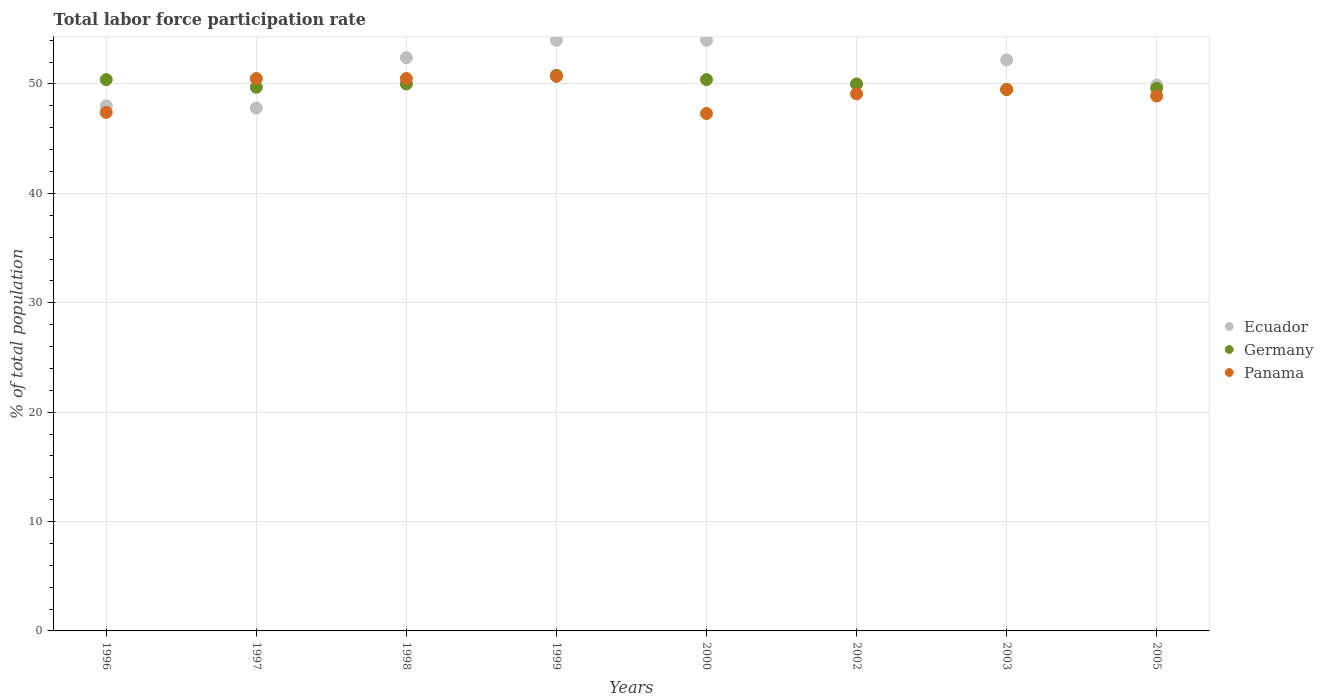Is the number of dotlines equal to the number of legend labels?
Keep it short and to the point. Yes. What is the total labor force participation rate in Germany in 1997?
Your answer should be compact. 49.7. Across all years, what is the maximum total labor force participation rate in Ecuador?
Provide a short and direct response. 54. Across all years, what is the minimum total labor force participation rate in Ecuador?
Provide a succinct answer. 47.8. In which year was the total labor force participation rate in Germany minimum?
Give a very brief answer. 2003. What is the total total labor force participation rate in Panama in the graph?
Provide a succinct answer. 393.9. What is the difference between the total labor force participation rate in Germany in 1997 and that in 2000?
Provide a short and direct response. -0.7. What is the difference between the total labor force participation rate in Ecuador in 2002 and the total labor force participation rate in Panama in 1997?
Provide a short and direct response. -0.5. What is the average total labor force participation rate in Germany per year?
Provide a succinct answer. 50.05. In the year 1997, what is the difference between the total labor force participation rate in Ecuador and total labor force participation rate in Panama?
Make the answer very short. -2.7. What is the ratio of the total labor force participation rate in Panama in 1997 to that in 2000?
Keep it short and to the point. 1.07. What is the difference between the highest and the second highest total labor force participation rate in Panama?
Provide a succinct answer. 0.2. What is the difference between the highest and the lowest total labor force participation rate in Ecuador?
Keep it short and to the point. 6.2. In how many years, is the total labor force participation rate in Germany greater than the average total labor force participation rate in Germany taken over all years?
Your response must be concise. 3. Is it the case that in every year, the sum of the total labor force participation rate in Ecuador and total labor force participation rate in Germany  is greater than the total labor force participation rate in Panama?
Offer a very short reply. Yes. Is the total labor force participation rate in Panama strictly greater than the total labor force participation rate in Ecuador over the years?
Provide a short and direct response. No. Is the total labor force participation rate in Germany strictly less than the total labor force participation rate in Ecuador over the years?
Make the answer very short. No. What is the difference between two consecutive major ticks on the Y-axis?
Your response must be concise. 10. How many legend labels are there?
Give a very brief answer. 3. What is the title of the graph?
Make the answer very short. Total labor force participation rate. What is the label or title of the Y-axis?
Your answer should be very brief. % of total population. What is the % of total population of Ecuador in 1996?
Make the answer very short. 48. What is the % of total population in Germany in 1996?
Make the answer very short. 50.4. What is the % of total population of Panama in 1996?
Give a very brief answer. 47.4. What is the % of total population in Ecuador in 1997?
Ensure brevity in your answer.  47.8. What is the % of total population in Germany in 1997?
Provide a succinct answer. 49.7. What is the % of total population of Panama in 1997?
Make the answer very short. 50.5. What is the % of total population of Ecuador in 1998?
Your answer should be compact. 52.4. What is the % of total population of Germany in 1998?
Offer a very short reply. 50. What is the % of total population in Panama in 1998?
Give a very brief answer. 50.5. What is the % of total population of Ecuador in 1999?
Your answer should be very brief. 54. What is the % of total population in Germany in 1999?
Offer a terse response. 50.8. What is the % of total population of Panama in 1999?
Your answer should be compact. 50.7. What is the % of total population in Germany in 2000?
Your response must be concise. 50.4. What is the % of total population of Panama in 2000?
Provide a short and direct response. 47.3. What is the % of total population of Ecuador in 2002?
Provide a succinct answer. 50. What is the % of total population in Germany in 2002?
Your answer should be very brief. 50. What is the % of total population in Panama in 2002?
Provide a succinct answer. 49.1. What is the % of total population of Ecuador in 2003?
Give a very brief answer. 52.2. What is the % of total population in Germany in 2003?
Provide a short and direct response. 49.5. What is the % of total population of Panama in 2003?
Your answer should be compact. 49.5. What is the % of total population of Ecuador in 2005?
Provide a succinct answer. 49.9. What is the % of total population of Germany in 2005?
Your answer should be very brief. 49.6. What is the % of total population of Panama in 2005?
Keep it short and to the point. 48.9. Across all years, what is the maximum % of total population of Germany?
Keep it short and to the point. 50.8. Across all years, what is the maximum % of total population in Panama?
Offer a very short reply. 50.7. Across all years, what is the minimum % of total population of Ecuador?
Provide a succinct answer. 47.8. Across all years, what is the minimum % of total population in Germany?
Offer a very short reply. 49.5. Across all years, what is the minimum % of total population in Panama?
Give a very brief answer. 47.3. What is the total % of total population of Ecuador in the graph?
Offer a terse response. 408.3. What is the total % of total population of Germany in the graph?
Give a very brief answer. 400.4. What is the total % of total population in Panama in the graph?
Provide a succinct answer. 393.9. What is the difference between the % of total population of Ecuador in 1996 and that in 1997?
Provide a succinct answer. 0.2. What is the difference between the % of total population of Panama in 1996 and that in 1997?
Ensure brevity in your answer.  -3.1. What is the difference between the % of total population in Panama in 1996 and that in 1998?
Your answer should be very brief. -3.1. What is the difference between the % of total population of Ecuador in 1996 and that in 1999?
Your answer should be very brief. -6. What is the difference between the % of total population of Germany in 1996 and that in 1999?
Offer a very short reply. -0.4. What is the difference between the % of total population of Germany in 1996 and that in 2000?
Ensure brevity in your answer.  0. What is the difference between the % of total population in Panama in 1996 and that in 2000?
Your answer should be very brief. 0.1. What is the difference between the % of total population of Germany in 1996 and that in 2002?
Provide a short and direct response. 0.4. What is the difference between the % of total population of Panama in 1996 and that in 2002?
Give a very brief answer. -1.7. What is the difference between the % of total population of Germany in 1996 and that in 2003?
Provide a short and direct response. 0.9. What is the difference between the % of total population in Germany in 1996 and that in 2005?
Make the answer very short. 0.8. What is the difference between the % of total population in Ecuador in 1997 and that in 1998?
Your answer should be very brief. -4.6. What is the difference between the % of total population of Germany in 1997 and that in 1998?
Keep it short and to the point. -0.3. What is the difference between the % of total population in Panama in 1997 and that in 1998?
Ensure brevity in your answer.  0. What is the difference between the % of total population of Panama in 1997 and that in 1999?
Provide a succinct answer. -0.2. What is the difference between the % of total population of Ecuador in 1997 and that in 2000?
Provide a succinct answer. -6.2. What is the difference between the % of total population in Panama in 1997 and that in 2000?
Offer a terse response. 3.2. What is the difference between the % of total population in Ecuador in 1997 and that in 2003?
Your response must be concise. -4.4. What is the difference between the % of total population in Panama in 1997 and that in 2003?
Provide a succinct answer. 1. What is the difference between the % of total population in Ecuador in 1997 and that in 2005?
Offer a very short reply. -2.1. What is the difference between the % of total population in Germany in 1997 and that in 2005?
Provide a succinct answer. 0.1. What is the difference between the % of total population of Panama in 1997 and that in 2005?
Provide a short and direct response. 1.6. What is the difference between the % of total population of Ecuador in 1998 and that in 1999?
Your answer should be very brief. -1.6. What is the difference between the % of total population in Ecuador in 1998 and that in 2000?
Your answer should be very brief. -1.6. What is the difference between the % of total population of Germany in 1998 and that in 2000?
Your answer should be compact. -0.4. What is the difference between the % of total population of Ecuador in 1998 and that in 2002?
Offer a terse response. 2.4. What is the difference between the % of total population of Ecuador in 1998 and that in 2003?
Make the answer very short. 0.2. What is the difference between the % of total population of Germany in 1998 and that in 2003?
Provide a short and direct response. 0.5. What is the difference between the % of total population in Panama in 1998 and that in 2003?
Offer a terse response. 1. What is the difference between the % of total population of Panama in 1998 and that in 2005?
Your answer should be very brief. 1.6. What is the difference between the % of total population of Ecuador in 1999 and that in 2002?
Keep it short and to the point. 4. What is the difference between the % of total population of Germany in 1999 and that in 2002?
Offer a terse response. 0.8. What is the difference between the % of total population in Panama in 1999 and that in 2002?
Offer a terse response. 1.6. What is the difference between the % of total population of Ecuador in 1999 and that in 2003?
Your answer should be very brief. 1.8. What is the difference between the % of total population in Germany in 1999 and that in 2003?
Offer a terse response. 1.3. What is the difference between the % of total population of Ecuador in 1999 and that in 2005?
Provide a short and direct response. 4.1. What is the difference between the % of total population in Germany in 1999 and that in 2005?
Provide a short and direct response. 1.2. What is the difference between the % of total population in Panama in 1999 and that in 2005?
Keep it short and to the point. 1.8. What is the difference between the % of total population in Germany in 2000 and that in 2002?
Make the answer very short. 0.4. What is the difference between the % of total population in Panama in 2000 and that in 2002?
Make the answer very short. -1.8. What is the difference between the % of total population in Ecuador in 2000 and that in 2003?
Offer a very short reply. 1.8. What is the difference between the % of total population in Panama in 2000 and that in 2003?
Provide a short and direct response. -2.2. What is the difference between the % of total population in Panama in 2000 and that in 2005?
Ensure brevity in your answer.  -1.6. What is the difference between the % of total population of Germany in 2002 and that in 2003?
Offer a terse response. 0.5. What is the difference between the % of total population of Germany in 2002 and that in 2005?
Your response must be concise. 0.4. What is the difference between the % of total population in Panama in 2002 and that in 2005?
Offer a very short reply. 0.2. What is the difference between the % of total population of Panama in 2003 and that in 2005?
Your response must be concise. 0.6. What is the difference between the % of total population in Germany in 1996 and the % of total population in Panama in 1997?
Ensure brevity in your answer.  -0.1. What is the difference between the % of total population in Germany in 1996 and the % of total population in Panama in 1998?
Keep it short and to the point. -0.1. What is the difference between the % of total population in Ecuador in 1996 and the % of total population in Germany in 1999?
Ensure brevity in your answer.  -2.8. What is the difference between the % of total population in Ecuador in 1996 and the % of total population in Panama in 1999?
Provide a succinct answer. -2.7. What is the difference between the % of total population in Germany in 1996 and the % of total population in Panama in 1999?
Provide a succinct answer. -0.3. What is the difference between the % of total population of Germany in 1996 and the % of total population of Panama in 2000?
Keep it short and to the point. 3.1. What is the difference between the % of total population in Ecuador in 1996 and the % of total population in Germany in 2002?
Your answer should be compact. -2. What is the difference between the % of total population of Germany in 1996 and the % of total population of Panama in 2002?
Keep it short and to the point. 1.3. What is the difference between the % of total population in Ecuador in 1996 and the % of total population in Germany in 2003?
Make the answer very short. -1.5. What is the difference between the % of total population of Ecuador in 1996 and the % of total population of Germany in 2005?
Provide a succinct answer. -1.6. What is the difference between the % of total population in Ecuador in 1996 and the % of total population in Panama in 2005?
Keep it short and to the point. -0.9. What is the difference between the % of total population in Ecuador in 1997 and the % of total population in Panama in 1998?
Your answer should be very brief. -2.7. What is the difference between the % of total population of Germany in 1997 and the % of total population of Panama in 1998?
Your answer should be very brief. -0.8. What is the difference between the % of total population in Ecuador in 1997 and the % of total population in Germany in 1999?
Offer a terse response. -3. What is the difference between the % of total population of Germany in 1997 and the % of total population of Panama in 1999?
Your answer should be very brief. -1. What is the difference between the % of total population of Ecuador in 1997 and the % of total population of Germany in 2000?
Offer a terse response. -2.6. What is the difference between the % of total population of Ecuador in 1997 and the % of total population of Panama in 2000?
Offer a terse response. 0.5. What is the difference between the % of total population of Germany in 1997 and the % of total population of Panama in 2000?
Your answer should be very brief. 2.4. What is the difference between the % of total population of Ecuador in 1997 and the % of total population of Germany in 2002?
Ensure brevity in your answer.  -2.2. What is the difference between the % of total population in Ecuador in 1997 and the % of total population in Panama in 2002?
Ensure brevity in your answer.  -1.3. What is the difference between the % of total population of Germany in 1997 and the % of total population of Panama in 2002?
Keep it short and to the point. 0.6. What is the difference between the % of total population in Ecuador in 1997 and the % of total population in Germany in 2003?
Keep it short and to the point. -1.7. What is the difference between the % of total population of Germany in 1997 and the % of total population of Panama in 2003?
Ensure brevity in your answer.  0.2. What is the difference between the % of total population in Ecuador in 1997 and the % of total population in Panama in 2005?
Give a very brief answer. -1.1. What is the difference between the % of total population in Germany in 1997 and the % of total population in Panama in 2005?
Make the answer very short. 0.8. What is the difference between the % of total population in Ecuador in 1998 and the % of total population in Germany in 1999?
Offer a very short reply. 1.6. What is the difference between the % of total population of Ecuador in 1998 and the % of total population of Germany in 2000?
Offer a terse response. 2. What is the difference between the % of total population of Germany in 1998 and the % of total population of Panama in 2000?
Your answer should be compact. 2.7. What is the difference between the % of total population of Ecuador in 1998 and the % of total population of Panama in 2002?
Offer a terse response. 3.3. What is the difference between the % of total population of Germany in 1998 and the % of total population of Panama in 2002?
Provide a succinct answer. 0.9. What is the difference between the % of total population of Ecuador in 1998 and the % of total population of Germany in 2003?
Offer a very short reply. 2.9. What is the difference between the % of total population of Ecuador in 1998 and the % of total population of Panama in 2003?
Your answer should be very brief. 2.9. What is the difference between the % of total population of Germany in 1998 and the % of total population of Panama in 2003?
Give a very brief answer. 0.5. What is the difference between the % of total population of Ecuador in 1998 and the % of total population of Panama in 2005?
Your answer should be very brief. 3.5. What is the difference between the % of total population in Ecuador in 1999 and the % of total population in Germany in 2000?
Give a very brief answer. 3.6. What is the difference between the % of total population of Germany in 1999 and the % of total population of Panama in 2000?
Give a very brief answer. 3.5. What is the difference between the % of total population of Ecuador in 1999 and the % of total population of Panama in 2002?
Provide a succinct answer. 4.9. What is the difference between the % of total population of Germany in 1999 and the % of total population of Panama in 2002?
Give a very brief answer. 1.7. What is the difference between the % of total population in Ecuador in 1999 and the % of total population in Germany in 2003?
Your answer should be very brief. 4.5. What is the difference between the % of total population of Ecuador in 1999 and the % of total population of Panama in 2003?
Ensure brevity in your answer.  4.5. What is the difference between the % of total population in Ecuador in 2000 and the % of total population in Germany in 2002?
Provide a succinct answer. 4. What is the difference between the % of total population in Germany in 2000 and the % of total population in Panama in 2002?
Keep it short and to the point. 1.3. What is the difference between the % of total population of Ecuador in 2000 and the % of total population of Germany in 2003?
Offer a terse response. 4.5. What is the difference between the % of total population in Ecuador in 2000 and the % of total population in Germany in 2005?
Provide a succinct answer. 4.4. What is the difference between the % of total population of Ecuador in 2000 and the % of total population of Panama in 2005?
Your answer should be very brief. 5.1. What is the difference between the % of total population of Germany in 2000 and the % of total population of Panama in 2005?
Keep it short and to the point. 1.5. What is the difference between the % of total population in Ecuador in 2002 and the % of total population in Germany in 2003?
Your response must be concise. 0.5. What is the difference between the % of total population in Ecuador in 2003 and the % of total population in Germany in 2005?
Ensure brevity in your answer.  2.6. What is the difference between the % of total population of Germany in 2003 and the % of total population of Panama in 2005?
Give a very brief answer. 0.6. What is the average % of total population in Ecuador per year?
Offer a terse response. 51.04. What is the average % of total population in Germany per year?
Make the answer very short. 50.05. What is the average % of total population of Panama per year?
Keep it short and to the point. 49.24. In the year 1997, what is the difference between the % of total population in Ecuador and % of total population in Germany?
Provide a short and direct response. -1.9. In the year 1997, what is the difference between the % of total population in Germany and % of total population in Panama?
Keep it short and to the point. -0.8. In the year 1999, what is the difference between the % of total population in Ecuador and % of total population in Germany?
Make the answer very short. 3.2. In the year 1999, what is the difference between the % of total population in Germany and % of total population in Panama?
Offer a very short reply. 0.1. In the year 2000, what is the difference between the % of total population of Ecuador and % of total population of Germany?
Your answer should be very brief. 3.6. In the year 2000, what is the difference between the % of total population in Ecuador and % of total population in Panama?
Offer a terse response. 6.7. In the year 2002, what is the difference between the % of total population of Ecuador and % of total population of Panama?
Offer a very short reply. 0.9. In the year 2002, what is the difference between the % of total population in Germany and % of total population in Panama?
Provide a succinct answer. 0.9. In the year 2003, what is the difference between the % of total population of Ecuador and % of total population of Germany?
Offer a terse response. 2.7. In the year 2003, what is the difference between the % of total population of Ecuador and % of total population of Panama?
Ensure brevity in your answer.  2.7. In the year 2003, what is the difference between the % of total population in Germany and % of total population in Panama?
Offer a terse response. 0. In the year 2005, what is the difference between the % of total population in Germany and % of total population in Panama?
Keep it short and to the point. 0.7. What is the ratio of the % of total population in Germany in 1996 to that in 1997?
Your answer should be compact. 1.01. What is the ratio of the % of total population in Panama in 1996 to that in 1997?
Provide a short and direct response. 0.94. What is the ratio of the % of total population in Ecuador in 1996 to that in 1998?
Ensure brevity in your answer.  0.92. What is the ratio of the % of total population in Germany in 1996 to that in 1998?
Keep it short and to the point. 1.01. What is the ratio of the % of total population in Panama in 1996 to that in 1998?
Keep it short and to the point. 0.94. What is the ratio of the % of total population in Ecuador in 1996 to that in 1999?
Offer a very short reply. 0.89. What is the ratio of the % of total population in Panama in 1996 to that in 1999?
Your answer should be very brief. 0.93. What is the ratio of the % of total population in Ecuador in 1996 to that in 2000?
Your answer should be very brief. 0.89. What is the ratio of the % of total population of Germany in 1996 to that in 2000?
Offer a terse response. 1. What is the ratio of the % of total population in Panama in 1996 to that in 2000?
Offer a very short reply. 1. What is the ratio of the % of total population of Germany in 1996 to that in 2002?
Provide a succinct answer. 1.01. What is the ratio of the % of total population in Panama in 1996 to that in 2002?
Provide a short and direct response. 0.97. What is the ratio of the % of total population in Ecuador in 1996 to that in 2003?
Provide a succinct answer. 0.92. What is the ratio of the % of total population of Germany in 1996 to that in 2003?
Provide a short and direct response. 1.02. What is the ratio of the % of total population of Panama in 1996 to that in 2003?
Offer a very short reply. 0.96. What is the ratio of the % of total population in Ecuador in 1996 to that in 2005?
Your response must be concise. 0.96. What is the ratio of the % of total population of Germany in 1996 to that in 2005?
Provide a succinct answer. 1.02. What is the ratio of the % of total population of Panama in 1996 to that in 2005?
Ensure brevity in your answer.  0.97. What is the ratio of the % of total population of Ecuador in 1997 to that in 1998?
Offer a very short reply. 0.91. What is the ratio of the % of total population of Germany in 1997 to that in 1998?
Your answer should be very brief. 0.99. What is the ratio of the % of total population in Panama in 1997 to that in 1998?
Your answer should be very brief. 1. What is the ratio of the % of total population in Ecuador in 1997 to that in 1999?
Keep it short and to the point. 0.89. What is the ratio of the % of total population in Germany in 1997 to that in 1999?
Provide a short and direct response. 0.98. What is the ratio of the % of total population in Panama in 1997 to that in 1999?
Your answer should be compact. 1. What is the ratio of the % of total population of Ecuador in 1997 to that in 2000?
Offer a terse response. 0.89. What is the ratio of the % of total population in Germany in 1997 to that in 2000?
Provide a succinct answer. 0.99. What is the ratio of the % of total population of Panama in 1997 to that in 2000?
Ensure brevity in your answer.  1.07. What is the ratio of the % of total population of Ecuador in 1997 to that in 2002?
Your response must be concise. 0.96. What is the ratio of the % of total population of Panama in 1997 to that in 2002?
Your answer should be compact. 1.03. What is the ratio of the % of total population of Ecuador in 1997 to that in 2003?
Your answer should be compact. 0.92. What is the ratio of the % of total population in Germany in 1997 to that in 2003?
Give a very brief answer. 1. What is the ratio of the % of total population of Panama in 1997 to that in 2003?
Your response must be concise. 1.02. What is the ratio of the % of total population in Ecuador in 1997 to that in 2005?
Provide a succinct answer. 0.96. What is the ratio of the % of total population in Germany in 1997 to that in 2005?
Ensure brevity in your answer.  1. What is the ratio of the % of total population of Panama in 1997 to that in 2005?
Make the answer very short. 1.03. What is the ratio of the % of total population of Ecuador in 1998 to that in 1999?
Make the answer very short. 0.97. What is the ratio of the % of total population in Germany in 1998 to that in 1999?
Offer a terse response. 0.98. What is the ratio of the % of total population of Panama in 1998 to that in 1999?
Offer a terse response. 1. What is the ratio of the % of total population of Ecuador in 1998 to that in 2000?
Ensure brevity in your answer.  0.97. What is the ratio of the % of total population in Germany in 1998 to that in 2000?
Your answer should be compact. 0.99. What is the ratio of the % of total population of Panama in 1998 to that in 2000?
Give a very brief answer. 1.07. What is the ratio of the % of total population of Ecuador in 1998 to that in 2002?
Offer a very short reply. 1.05. What is the ratio of the % of total population in Germany in 1998 to that in 2002?
Offer a very short reply. 1. What is the ratio of the % of total population of Panama in 1998 to that in 2002?
Ensure brevity in your answer.  1.03. What is the ratio of the % of total population of Ecuador in 1998 to that in 2003?
Make the answer very short. 1. What is the ratio of the % of total population in Panama in 1998 to that in 2003?
Make the answer very short. 1.02. What is the ratio of the % of total population of Ecuador in 1998 to that in 2005?
Give a very brief answer. 1.05. What is the ratio of the % of total population in Germany in 1998 to that in 2005?
Keep it short and to the point. 1.01. What is the ratio of the % of total population of Panama in 1998 to that in 2005?
Make the answer very short. 1.03. What is the ratio of the % of total population of Ecuador in 1999 to that in 2000?
Give a very brief answer. 1. What is the ratio of the % of total population of Germany in 1999 to that in 2000?
Your answer should be very brief. 1.01. What is the ratio of the % of total population of Panama in 1999 to that in 2000?
Your response must be concise. 1.07. What is the ratio of the % of total population of Germany in 1999 to that in 2002?
Provide a succinct answer. 1.02. What is the ratio of the % of total population in Panama in 1999 to that in 2002?
Keep it short and to the point. 1.03. What is the ratio of the % of total population in Ecuador in 1999 to that in 2003?
Provide a short and direct response. 1.03. What is the ratio of the % of total population of Germany in 1999 to that in 2003?
Your answer should be very brief. 1.03. What is the ratio of the % of total population in Panama in 1999 to that in 2003?
Keep it short and to the point. 1.02. What is the ratio of the % of total population in Ecuador in 1999 to that in 2005?
Provide a short and direct response. 1.08. What is the ratio of the % of total population in Germany in 1999 to that in 2005?
Make the answer very short. 1.02. What is the ratio of the % of total population of Panama in 1999 to that in 2005?
Make the answer very short. 1.04. What is the ratio of the % of total population in Panama in 2000 to that in 2002?
Offer a very short reply. 0.96. What is the ratio of the % of total population of Ecuador in 2000 to that in 2003?
Provide a succinct answer. 1.03. What is the ratio of the % of total population in Germany in 2000 to that in 2003?
Make the answer very short. 1.02. What is the ratio of the % of total population in Panama in 2000 to that in 2003?
Give a very brief answer. 0.96. What is the ratio of the % of total population of Ecuador in 2000 to that in 2005?
Your response must be concise. 1.08. What is the ratio of the % of total population in Germany in 2000 to that in 2005?
Offer a very short reply. 1.02. What is the ratio of the % of total population of Panama in 2000 to that in 2005?
Your answer should be very brief. 0.97. What is the ratio of the % of total population in Ecuador in 2002 to that in 2003?
Provide a short and direct response. 0.96. What is the ratio of the % of total population of Germany in 2002 to that in 2003?
Offer a terse response. 1.01. What is the ratio of the % of total population of Panama in 2002 to that in 2003?
Provide a succinct answer. 0.99. What is the ratio of the % of total population in Ecuador in 2002 to that in 2005?
Make the answer very short. 1. What is the ratio of the % of total population of Germany in 2002 to that in 2005?
Keep it short and to the point. 1.01. What is the ratio of the % of total population in Panama in 2002 to that in 2005?
Keep it short and to the point. 1. What is the ratio of the % of total population of Ecuador in 2003 to that in 2005?
Offer a very short reply. 1.05. What is the ratio of the % of total population in Germany in 2003 to that in 2005?
Your answer should be compact. 1. What is the ratio of the % of total population of Panama in 2003 to that in 2005?
Keep it short and to the point. 1.01. What is the difference between the highest and the second highest % of total population of Panama?
Give a very brief answer. 0.2. What is the difference between the highest and the lowest % of total population of Germany?
Your answer should be compact. 1.3. 